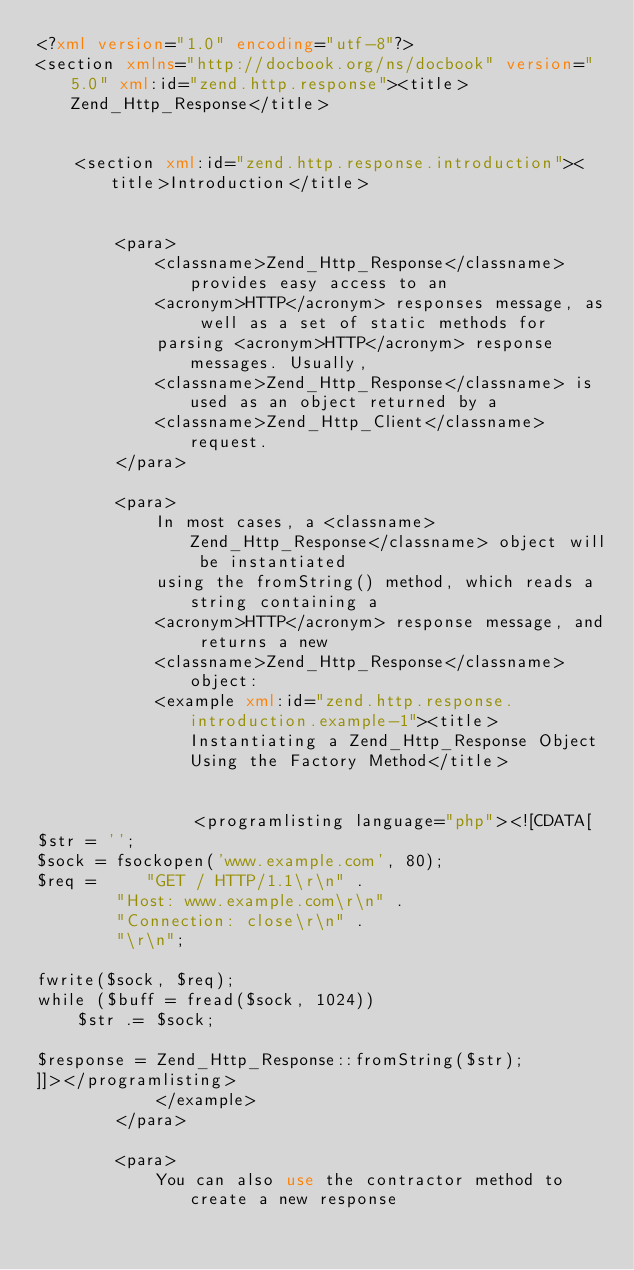<code> <loc_0><loc_0><loc_500><loc_500><_XML_><?xml version="1.0" encoding="utf-8"?>
<section xmlns="http://docbook.org/ns/docbook" version="5.0" xml:id="zend.http.response"><title>Zend_Http_Response</title>
    

    <section xml:id="zend.http.response.introduction"><title>Introduction</title>
        

        <para>
            <classname>Zend_Http_Response</classname> provides easy access to an
            <acronym>HTTP</acronym> responses message, as well as a set of static methods for
            parsing <acronym>HTTP</acronym> response messages. Usually,
            <classname>Zend_Http_Response</classname> is used as an object returned by a
            <classname>Zend_Http_Client</classname> request.
        </para>

        <para>
            In most cases, a <classname>Zend_Http_Response</classname> object will be instantiated
            using the fromString() method, which reads a string containing a
            <acronym>HTTP</acronym> response message, and returns a new
            <classname>Zend_Http_Response</classname> object:
            <example xml:id="zend.http.response.introduction.example-1"><title>Instantiating a Zend_Http_Response Object Using the Factory Method</title>
                

                <programlisting language="php"><![CDATA[
$str = '';
$sock = fsockopen('www.example.com', 80);
$req =     "GET / HTTP/1.1\r\n" .
        "Host: www.example.com\r\n" .
        "Connection: close\r\n" .
        "\r\n";

fwrite($sock, $req);
while ($buff = fread($sock, 1024))
    $str .= $sock;

$response = Zend_Http_Response::fromString($str);
]]></programlisting>
            </example>
        </para>

        <para>
            You can also use the contractor method to create a new response</code> 